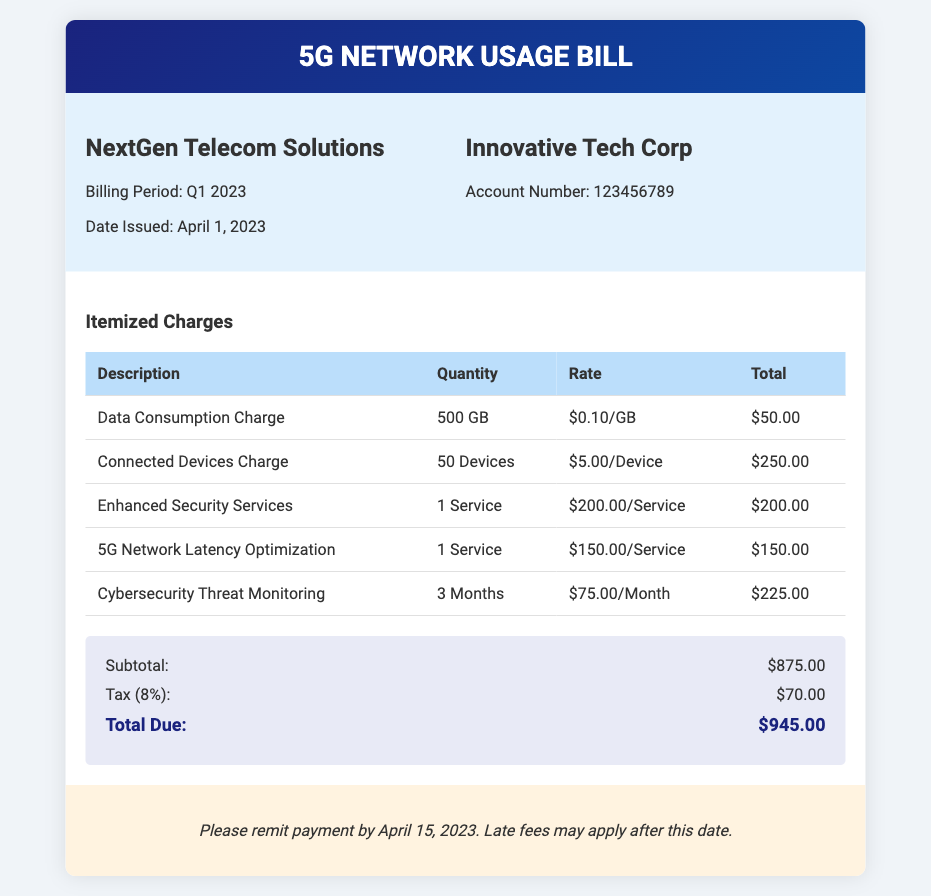What is the billing period? The billing period for this document is specified in the "Billing Period" section, which states it is Q1 2023.
Answer: Q1 2023 What is the date issued? The date issued for the bill is found under the "Bill Info" section, which lists the date as April 1, 2023.
Answer: April 1, 2023 How many connected devices were charged? The number of connected devices charged is found in the itemized charges table, which shows 50 devices.
Answer: 50 Devices What is the rate for data consumption? The rate for data consumption is presented in the itemized charges under the "Data Consumption Charge," which is $0.10/GB.
Answer: $0.10/GB What is the subtotal amount? The subtotal amount can be found in the summary section, which states the subtotal is $875.00.
Answer: $875.00 What service is included for enhanced security? The enhanced security service has a description listed in the itemized charges, which is "Enhanced Security Services."
Answer: Enhanced Security Services How much is the tax applied? The tax amount is stated in the summary section as $70.00, calculated as 8% of the subtotal.
Answer: $70.00 What is the total due amount? The total due amount is summarized at the bottom of the document, which is indicated as $945.00.
Answer: $945.00 What is the payment due date? The payment due date is specified in the payment instructions section, which states to remit payment by April 15, 2023.
Answer: April 15, 2023 